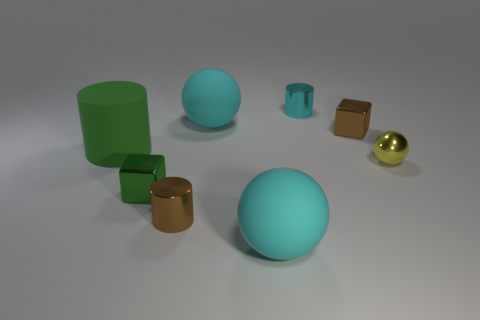Is there a cyan thing made of the same material as the cyan cylinder? no 